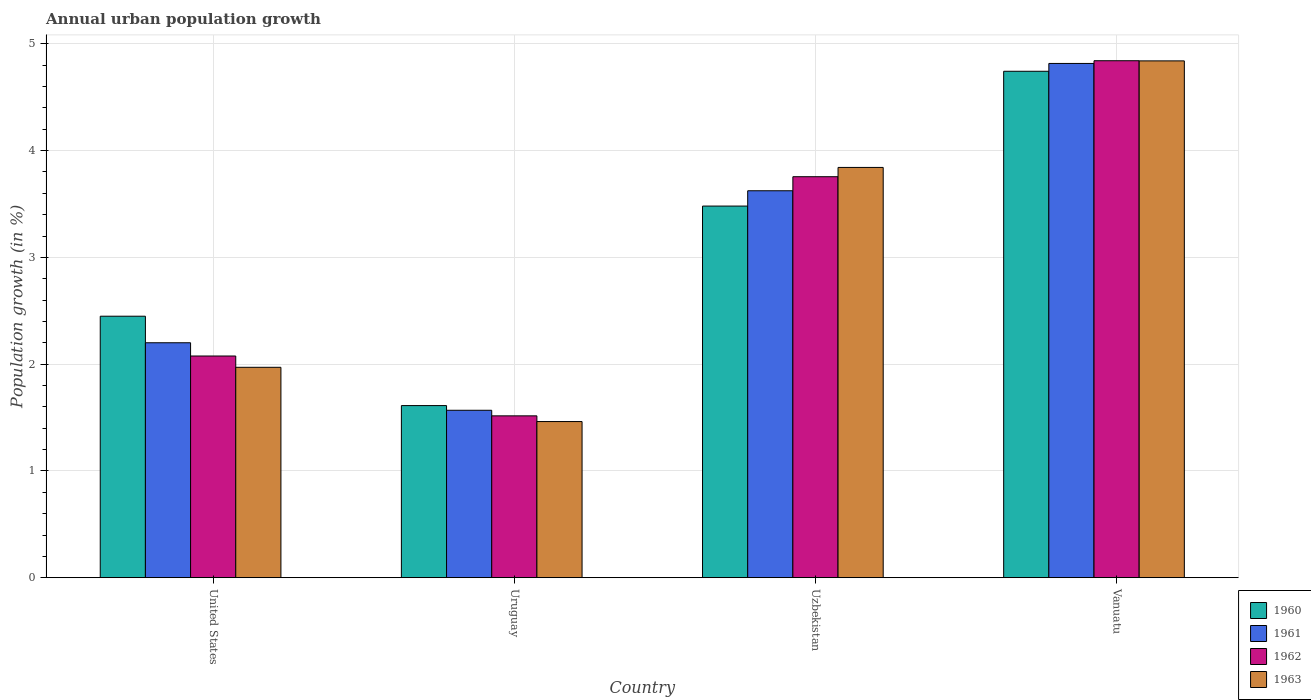How many different coloured bars are there?
Ensure brevity in your answer.  4. How many groups of bars are there?
Make the answer very short. 4. Are the number of bars per tick equal to the number of legend labels?
Provide a succinct answer. Yes. Are the number of bars on each tick of the X-axis equal?
Provide a short and direct response. Yes. How many bars are there on the 3rd tick from the left?
Give a very brief answer. 4. What is the label of the 3rd group of bars from the left?
Offer a very short reply. Uzbekistan. What is the percentage of urban population growth in 1961 in Vanuatu?
Provide a succinct answer. 4.82. Across all countries, what is the maximum percentage of urban population growth in 1962?
Your answer should be compact. 4.84. Across all countries, what is the minimum percentage of urban population growth in 1960?
Your response must be concise. 1.61. In which country was the percentage of urban population growth in 1963 maximum?
Give a very brief answer. Vanuatu. In which country was the percentage of urban population growth in 1963 minimum?
Your response must be concise. Uruguay. What is the total percentage of urban population growth in 1960 in the graph?
Ensure brevity in your answer.  12.29. What is the difference between the percentage of urban population growth in 1962 in Uzbekistan and that in Vanuatu?
Give a very brief answer. -1.09. What is the difference between the percentage of urban population growth in 1962 in Vanuatu and the percentage of urban population growth in 1963 in United States?
Offer a terse response. 2.87. What is the average percentage of urban population growth in 1962 per country?
Your response must be concise. 3.05. What is the difference between the percentage of urban population growth of/in 1960 and percentage of urban population growth of/in 1961 in Uruguay?
Provide a succinct answer. 0.04. What is the ratio of the percentage of urban population growth in 1962 in United States to that in Uzbekistan?
Ensure brevity in your answer.  0.55. Is the percentage of urban population growth in 1960 in United States less than that in Uruguay?
Provide a short and direct response. No. What is the difference between the highest and the second highest percentage of urban population growth in 1960?
Your response must be concise. -1.03. What is the difference between the highest and the lowest percentage of urban population growth in 1960?
Offer a terse response. 3.13. In how many countries, is the percentage of urban population growth in 1960 greater than the average percentage of urban population growth in 1960 taken over all countries?
Your answer should be very brief. 2. Is the sum of the percentage of urban population growth in 1960 in Uzbekistan and Vanuatu greater than the maximum percentage of urban population growth in 1961 across all countries?
Make the answer very short. Yes. Is it the case that in every country, the sum of the percentage of urban population growth in 1963 and percentage of urban population growth in 1961 is greater than the sum of percentage of urban population growth in 1960 and percentage of urban population growth in 1962?
Your response must be concise. No. What does the 3rd bar from the left in United States represents?
Keep it short and to the point. 1962. What does the 1st bar from the right in Uruguay represents?
Your response must be concise. 1963. Is it the case that in every country, the sum of the percentage of urban population growth in 1962 and percentage of urban population growth in 1963 is greater than the percentage of urban population growth in 1961?
Ensure brevity in your answer.  Yes. How many bars are there?
Offer a very short reply. 16. How many countries are there in the graph?
Offer a terse response. 4. Does the graph contain any zero values?
Keep it short and to the point. No. Does the graph contain grids?
Offer a very short reply. Yes. Where does the legend appear in the graph?
Provide a succinct answer. Bottom right. What is the title of the graph?
Your response must be concise. Annual urban population growth. What is the label or title of the X-axis?
Keep it short and to the point. Country. What is the label or title of the Y-axis?
Provide a succinct answer. Population growth (in %). What is the Population growth (in %) of 1960 in United States?
Offer a terse response. 2.45. What is the Population growth (in %) in 1961 in United States?
Your answer should be very brief. 2.2. What is the Population growth (in %) of 1962 in United States?
Your answer should be compact. 2.08. What is the Population growth (in %) in 1963 in United States?
Your response must be concise. 1.97. What is the Population growth (in %) in 1960 in Uruguay?
Your answer should be compact. 1.61. What is the Population growth (in %) of 1961 in Uruguay?
Your answer should be compact. 1.57. What is the Population growth (in %) in 1962 in Uruguay?
Your answer should be very brief. 1.52. What is the Population growth (in %) in 1963 in Uruguay?
Keep it short and to the point. 1.46. What is the Population growth (in %) in 1960 in Uzbekistan?
Your response must be concise. 3.48. What is the Population growth (in %) in 1961 in Uzbekistan?
Your response must be concise. 3.62. What is the Population growth (in %) of 1962 in Uzbekistan?
Give a very brief answer. 3.76. What is the Population growth (in %) in 1963 in Uzbekistan?
Ensure brevity in your answer.  3.84. What is the Population growth (in %) of 1960 in Vanuatu?
Offer a very short reply. 4.74. What is the Population growth (in %) in 1961 in Vanuatu?
Make the answer very short. 4.82. What is the Population growth (in %) in 1962 in Vanuatu?
Give a very brief answer. 4.84. What is the Population growth (in %) in 1963 in Vanuatu?
Your answer should be compact. 4.84. Across all countries, what is the maximum Population growth (in %) in 1960?
Provide a succinct answer. 4.74. Across all countries, what is the maximum Population growth (in %) in 1961?
Give a very brief answer. 4.82. Across all countries, what is the maximum Population growth (in %) of 1962?
Provide a succinct answer. 4.84. Across all countries, what is the maximum Population growth (in %) in 1963?
Offer a very short reply. 4.84. Across all countries, what is the minimum Population growth (in %) in 1960?
Your response must be concise. 1.61. Across all countries, what is the minimum Population growth (in %) of 1961?
Offer a very short reply. 1.57. Across all countries, what is the minimum Population growth (in %) of 1962?
Ensure brevity in your answer.  1.52. Across all countries, what is the minimum Population growth (in %) in 1963?
Your answer should be compact. 1.46. What is the total Population growth (in %) of 1960 in the graph?
Your answer should be compact. 12.29. What is the total Population growth (in %) of 1961 in the graph?
Provide a succinct answer. 12.21. What is the total Population growth (in %) in 1962 in the graph?
Offer a very short reply. 12.19. What is the total Population growth (in %) of 1963 in the graph?
Your response must be concise. 12.12. What is the difference between the Population growth (in %) of 1960 in United States and that in Uruguay?
Keep it short and to the point. 0.84. What is the difference between the Population growth (in %) of 1961 in United States and that in Uruguay?
Provide a short and direct response. 0.63. What is the difference between the Population growth (in %) of 1962 in United States and that in Uruguay?
Ensure brevity in your answer.  0.56. What is the difference between the Population growth (in %) in 1963 in United States and that in Uruguay?
Your answer should be very brief. 0.51. What is the difference between the Population growth (in %) of 1960 in United States and that in Uzbekistan?
Offer a terse response. -1.03. What is the difference between the Population growth (in %) of 1961 in United States and that in Uzbekistan?
Your response must be concise. -1.42. What is the difference between the Population growth (in %) in 1962 in United States and that in Uzbekistan?
Keep it short and to the point. -1.68. What is the difference between the Population growth (in %) in 1963 in United States and that in Uzbekistan?
Make the answer very short. -1.87. What is the difference between the Population growth (in %) of 1960 in United States and that in Vanuatu?
Keep it short and to the point. -2.29. What is the difference between the Population growth (in %) in 1961 in United States and that in Vanuatu?
Give a very brief answer. -2.62. What is the difference between the Population growth (in %) in 1962 in United States and that in Vanuatu?
Your answer should be very brief. -2.77. What is the difference between the Population growth (in %) in 1963 in United States and that in Vanuatu?
Give a very brief answer. -2.87. What is the difference between the Population growth (in %) in 1960 in Uruguay and that in Uzbekistan?
Make the answer very short. -1.87. What is the difference between the Population growth (in %) in 1961 in Uruguay and that in Uzbekistan?
Provide a succinct answer. -2.06. What is the difference between the Population growth (in %) in 1962 in Uruguay and that in Uzbekistan?
Provide a succinct answer. -2.24. What is the difference between the Population growth (in %) in 1963 in Uruguay and that in Uzbekistan?
Your answer should be very brief. -2.38. What is the difference between the Population growth (in %) of 1960 in Uruguay and that in Vanuatu?
Offer a very short reply. -3.13. What is the difference between the Population growth (in %) in 1961 in Uruguay and that in Vanuatu?
Provide a short and direct response. -3.25. What is the difference between the Population growth (in %) of 1962 in Uruguay and that in Vanuatu?
Keep it short and to the point. -3.33. What is the difference between the Population growth (in %) of 1963 in Uruguay and that in Vanuatu?
Make the answer very short. -3.38. What is the difference between the Population growth (in %) of 1960 in Uzbekistan and that in Vanuatu?
Make the answer very short. -1.26. What is the difference between the Population growth (in %) in 1961 in Uzbekistan and that in Vanuatu?
Provide a succinct answer. -1.19. What is the difference between the Population growth (in %) of 1962 in Uzbekistan and that in Vanuatu?
Your answer should be very brief. -1.09. What is the difference between the Population growth (in %) of 1963 in Uzbekistan and that in Vanuatu?
Provide a succinct answer. -1. What is the difference between the Population growth (in %) in 1960 in United States and the Population growth (in %) in 1961 in Uruguay?
Offer a very short reply. 0.88. What is the difference between the Population growth (in %) of 1960 in United States and the Population growth (in %) of 1962 in Uruguay?
Your answer should be very brief. 0.93. What is the difference between the Population growth (in %) in 1960 in United States and the Population growth (in %) in 1963 in Uruguay?
Provide a succinct answer. 0.99. What is the difference between the Population growth (in %) in 1961 in United States and the Population growth (in %) in 1962 in Uruguay?
Offer a terse response. 0.68. What is the difference between the Population growth (in %) of 1961 in United States and the Population growth (in %) of 1963 in Uruguay?
Give a very brief answer. 0.74. What is the difference between the Population growth (in %) in 1962 in United States and the Population growth (in %) in 1963 in Uruguay?
Make the answer very short. 0.61. What is the difference between the Population growth (in %) in 1960 in United States and the Population growth (in %) in 1961 in Uzbekistan?
Offer a very short reply. -1.18. What is the difference between the Population growth (in %) in 1960 in United States and the Population growth (in %) in 1962 in Uzbekistan?
Give a very brief answer. -1.31. What is the difference between the Population growth (in %) in 1960 in United States and the Population growth (in %) in 1963 in Uzbekistan?
Your answer should be very brief. -1.39. What is the difference between the Population growth (in %) in 1961 in United States and the Population growth (in %) in 1962 in Uzbekistan?
Your answer should be compact. -1.56. What is the difference between the Population growth (in %) in 1961 in United States and the Population growth (in %) in 1963 in Uzbekistan?
Your response must be concise. -1.64. What is the difference between the Population growth (in %) in 1962 in United States and the Population growth (in %) in 1963 in Uzbekistan?
Offer a terse response. -1.77. What is the difference between the Population growth (in %) of 1960 in United States and the Population growth (in %) of 1961 in Vanuatu?
Ensure brevity in your answer.  -2.37. What is the difference between the Population growth (in %) of 1960 in United States and the Population growth (in %) of 1962 in Vanuatu?
Your answer should be compact. -2.39. What is the difference between the Population growth (in %) of 1960 in United States and the Population growth (in %) of 1963 in Vanuatu?
Your response must be concise. -2.39. What is the difference between the Population growth (in %) in 1961 in United States and the Population growth (in %) in 1962 in Vanuatu?
Your response must be concise. -2.64. What is the difference between the Population growth (in %) in 1961 in United States and the Population growth (in %) in 1963 in Vanuatu?
Provide a short and direct response. -2.64. What is the difference between the Population growth (in %) in 1962 in United States and the Population growth (in %) in 1963 in Vanuatu?
Provide a short and direct response. -2.76. What is the difference between the Population growth (in %) of 1960 in Uruguay and the Population growth (in %) of 1961 in Uzbekistan?
Make the answer very short. -2.01. What is the difference between the Population growth (in %) in 1960 in Uruguay and the Population growth (in %) in 1962 in Uzbekistan?
Your response must be concise. -2.14. What is the difference between the Population growth (in %) of 1960 in Uruguay and the Population growth (in %) of 1963 in Uzbekistan?
Your answer should be very brief. -2.23. What is the difference between the Population growth (in %) of 1961 in Uruguay and the Population growth (in %) of 1962 in Uzbekistan?
Keep it short and to the point. -2.19. What is the difference between the Population growth (in %) of 1961 in Uruguay and the Population growth (in %) of 1963 in Uzbekistan?
Your answer should be compact. -2.27. What is the difference between the Population growth (in %) of 1962 in Uruguay and the Population growth (in %) of 1963 in Uzbekistan?
Offer a terse response. -2.33. What is the difference between the Population growth (in %) of 1960 in Uruguay and the Population growth (in %) of 1961 in Vanuatu?
Offer a terse response. -3.2. What is the difference between the Population growth (in %) of 1960 in Uruguay and the Population growth (in %) of 1962 in Vanuatu?
Offer a very short reply. -3.23. What is the difference between the Population growth (in %) of 1960 in Uruguay and the Population growth (in %) of 1963 in Vanuatu?
Ensure brevity in your answer.  -3.23. What is the difference between the Population growth (in %) of 1961 in Uruguay and the Population growth (in %) of 1962 in Vanuatu?
Ensure brevity in your answer.  -3.27. What is the difference between the Population growth (in %) of 1961 in Uruguay and the Population growth (in %) of 1963 in Vanuatu?
Offer a terse response. -3.27. What is the difference between the Population growth (in %) in 1962 in Uruguay and the Population growth (in %) in 1963 in Vanuatu?
Keep it short and to the point. -3.32. What is the difference between the Population growth (in %) of 1960 in Uzbekistan and the Population growth (in %) of 1961 in Vanuatu?
Your response must be concise. -1.34. What is the difference between the Population growth (in %) in 1960 in Uzbekistan and the Population growth (in %) in 1962 in Vanuatu?
Provide a short and direct response. -1.36. What is the difference between the Population growth (in %) of 1960 in Uzbekistan and the Population growth (in %) of 1963 in Vanuatu?
Offer a very short reply. -1.36. What is the difference between the Population growth (in %) of 1961 in Uzbekistan and the Population growth (in %) of 1962 in Vanuatu?
Ensure brevity in your answer.  -1.22. What is the difference between the Population growth (in %) in 1961 in Uzbekistan and the Population growth (in %) in 1963 in Vanuatu?
Give a very brief answer. -1.22. What is the difference between the Population growth (in %) of 1962 in Uzbekistan and the Population growth (in %) of 1963 in Vanuatu?
Give a very brief answer. -1.08. What is the average Population growth (in %) in 1960 per country?
Offer a very short reply. 3.07. What is the average Population growth (in %) of 1961 per country?
Make the answer very short. 3.05. What is the average Population growth (in %) of 1962 per country?
Ensure brevity in your answer.  3.05. What is the average Population growth (in %) of 1963 per country?
Offer a very short reply. 3.03. What is the difference between the Population growth (in %) in 1960 and Population growth (in %) in 1961 in United States?
Your answer should be very brief. 0.25. What is the difference between the Population growth (in %) of 1960 and Population growth (in %) of 1962 in United States?
Offer a very short reply. 0.37. What is the difference between the Population growth (in %) of 1960 and Population growth (in %) of 1963 in United States?
Keep it short and to the point. 0.48. What is the difference between the Population growth (in %) in 1961 and Population growth (in %) in 1962 in United States?
Offer a very short reply. 0.12. What is the difference between the Population growth (in %) of 1961 and Population growth (in %) of 1963 in United States?
Provide a short and direct response. 0.23. What is the difference between the Population growth (in %) in 1962 and Population growth (in %) in 1963 in United States?
Make the answer very short. 0.11. What is the difference between the Population growth (in %) of 1960 and Population growth (in %) of 1961 in Uruguay?
Keep it short and to the point. 0.04. What is the difference between the Population growth (in %) of 1960 and Population growth (in %) of 1962 in Uruguay?
Make the answer very short. 0.1. What is the difference between the Population growth (in %) of 1960 and Population growth (in %) of 1963 in Uruguay?
Provide a short and direct response. 0.15. What is the difference between the Population growth (in %) in 1961 and Population growth (in %) in 1962 in Uruguay?
Offer a terse response. 0.05. What is the difference between the Population growth (in %) of 1961 and Population growth (in %) of 1963 in Uruguay?
Make the answer very short. 0.11. What is the difference between the Population growth (in %) of 1962 and Population growth (in %) of 1963 in Uruguay?
Offer a very short reply. 0.05. What is the difference between the Population growth (in %) of 1960 and Population growth (in %) of 1961 in Uzbekistan?
Your answer should be compact. -0.14. What is the difference between the Population growth (in %) of 1960 and Population growth (in %) of 1962 in Uzbekistan?
Make the answer very short. -0.28. What is the difference between the Population growth (in %) of 1960 and Population growth (in %) of 1963 in Uzbekistan?
Provide a short and direct response. -0.36. What is the difference between the Population growth (in %) of 1961 and Population growth (in %) of 1962 in Uzbekistan?
Offer a very short reply. -0.13. What is the difference between the Population growth (in %) of 1961 and Population growth (in %) of 1963 in Uzbekistan?
Give a very brief answer. -0.22. What is the difference between the Population growth (in %) of 1962 and Population growth (in %) of 1963 in Uzbekistan?
Ensure brevity in your answer.  -0.09. What is the difference between the Population growth (in %) in 1960 and Population growth (in %) in 1961 in Vanuatu?
Provide a succinct answer. -0.07. What is the difference between the Population growth (in %) in 1960 and Population growth (in %) in 1962 in Vanuatu?
Give a very brief answer. -0.1. What is the difference between the Population growth (in %) of 1960 and Population growth (in %) of 1963 in Vanuatu?
Make the answer very short. -0.1. What is the difference between the Population growth (in %) in 1961 and Population growth (in %) in 1962 in Vanuatu?
Give a very brief answer. -0.03. What is the difference between the Population growth (in %) in 1961 and Population growth (in %) in 1963 in Vanuatu?
Your response must be concise. -0.02. What is the difference between the Population growth (in %) of 1962 and Population growth (in %) of 1963 in Vanuatu?
Give a very brief answer. 0. What is the ratio of the Population growth (in %) of 1960 in United States to that in Uruguay?
Provide a succinct answer. 1.52. What is the ratio of the Population growth (in %) in 1961 in United States to that in Uruguay?
Give a very brief answer. 1.4. What is the ratio of the Population growth (in %) in 1962 in United States to that in Uruguay?
Your response must be concise. 1.37. What is the ratio of the Population growth (in %) of 1963 in United States to that in Uruguay?
Keep it short and to the point. 1.35. What is the ratio of the Population growth (in %) of 1960 in United States to that in Uzbekistan?
Make the answer very short. 0.7. What is the ratio of the Population growth (in %) of 1961 in United States to that in Uzbekistan?
Keep it short and to the point. 0.61. What is the ratio of the Population growth (in %) of 1962 in United States to that in Uzbekistan?
Keep it short and to the point. 0.55. What is the ratio of the Population growth (in %) in 1963 in United States to that in Uzbekistan?
Your response must be concise. 0.51. What is the ratio of the Population growth (in %) of 1960 in United States to that in Vanuatu?
Make the answer very short. 0.52. What is the ratio of the Population growth (in %) in 1961 in United States to that in Vanuatu?
Offer a very short reply. 0.46. What is the ratio of the Population growth (in %) in 1962 in United States to that in Vanuatu?
Ensure brevity in your answer.  0.43. What is the ratio of the Population growth (in %) of 1963 in United States to that in Vanuatu?
Your answer should be compact. 0.41. What is the ratio of the Population growth (in %) of 1960 in Uruguay to that in Uzbekistan?
Keep it short and to the point. 0.46. What is the ratio of the Population growth (in %) of 1961 in Uruguay to that in Uzbekistan?
Provide a short and direct response. 0.43. What is the ratio of the Population growth (in %) of 1962 in Uruguay to that in Uzbekistan?
Provide a succinct answer. 0.4. What is the ratio of the Population growth (in %) in 1963 in Uruguay to that in Uzbekistan?
Provide a short and direct response. 0.38. What is the ratio of the Population growth (in %) of 1960 in Uruguay to that in Vanuatu?
Offer a terse response. 0.34. What is the ratio of the Population growth (in %) in 1961 in Uruguay to that in Vanuatu?
Give a very brief answer. 0.33. What is the ratio of the Population growth (in %) in 1962 in Uruguay to that in Vanuatu?
Offer a very short reply. 0.31. What is the ratio of the Population growth (in %) of 1963 in Uruguay to that in Vanuatu?
Keep it short and to the point. 0.3. What is the ratio of the Population growth (in %) of 1960 in Uzbekistan to that in Vanuatu?
Ensure brevity in your answer.  0.73. What is the ratio of the Population growth (in %) of 1961 in Uzbekistan to that in Vanuatu?
Ensure brevity in your answer.  0.75. What is the ratio of the Population growth (in %) in 1962 in Uzbekistan to that in Vanuatu?
Offer a very short reply. 0.78. What is the ratio of the Population growth (in %) of 1963 in Uzbekistan to that in Vanuatu?
Make the answer very short. 0.79. What is the difference between the highest and the second highest Population growth (in %) in 1960?
Make the answer very short. 1.26. What is the difference between the highest and the second highest Population growth (in %) of 1961?
Your response must be concise. 1.19. What is the difference between the highest and the second highest Population growth (in %) of 1962?
Your answer should be compact. 1.09. What is the difference between the highest and the lowest Population growth (in %) in 1960?
Provide a short and direct response. 3.13. What is the difference between the highest and the lowest Population growth (in %) in 1961?
Make the answer very short. 3.25. What is the difference between the highest and the lowest Population growth (in %) in 1962?
Your answer should be very brief. 3.33. What is the difference between the highest and the lowest Population growth (in %) of 1963?
Your answer should be compact. 3.38. 